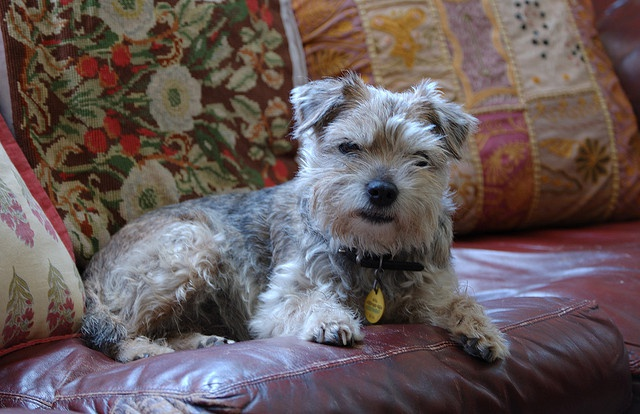Describe the objects in this image and their specific colors. I can see couch in maroon, gray, and black tones and dog in maroon, gray, darkgray, and black tones in this image. 